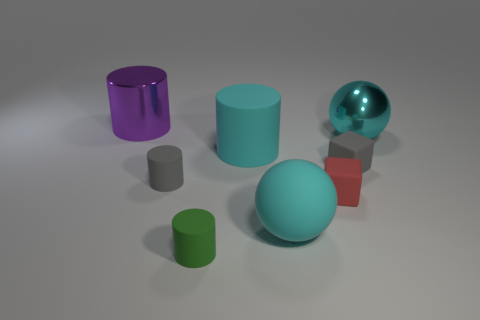The small green matte object is what shape?
Keep it short and to the point. Cylinder. Is the shape of the big object in front of the red matte thing the same as  the tiny red matte thing?
Provide a short and direct response. No. Is the number of large purple things to the right of the large purple shiny cylinder greater than the number of gray rubber things that are in front of the green matte thing?
Provide a short and direct response. No. How many other objects are the same size as the cyan cylinder?
Provide a succinct answer. 3. Do the cyan metal thing and the big thing that is behind the large cyan metal thing have the same shape?
Ensure brevity in your answer.  No. How many metallic objects are brown cubes or gray objects?
Ensure brevity in your answer.  0. Are there any big metallic spheres of the same color as the shiny cylinder?
Provide a short and direct response. No. Is there a cyan ball?
Offer a very short reply. Yes. Is the green object the same shape as the large cyan metal object?
Your answer should be compact. No. How many large things are cyan matte things or red rubber blocks?
Provide a short and direct response. 2. 